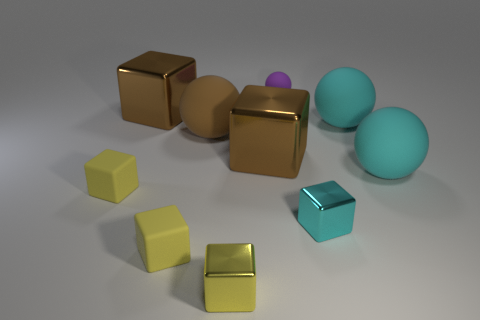Subtract all matte cubes. How many cubes are left? 4 Subtract all cyan balls. How many balls are left? 2 Subtract all blocks. How many objects are left? 4 Subtract 4 cubes. How many cubes are left? 2 Add 6 large matte cylinders. How many large matte cylinders exist? 6 Subtract 0 blue balls. How many objects are left? 10 Subtract all cyan spheres. Subtract all purple cylinders. How many spheres are left? 2 Subtract all blue cylinders. How many yellow cubes are left? 3 Subtract all large yellow cubes. Subtract all brown objects. How many objects are left? 7 Add 5 large shiny blocks. How many large shiny blocks are left? 7 